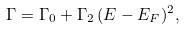Convert formula to latex. <formula><loc_0><loc_0><loc_500><loc_500>\Gamma = \Gamma _ { 0 } + \Gamma _ { 2 } \, ( E - E _ { F } ) ^ { 2 } ,</formula> 